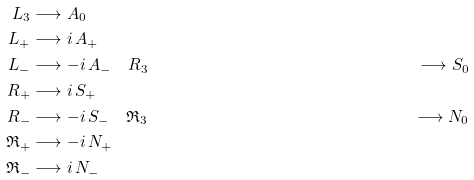Convert formula to latex. <formula><loc_0><loc_0><loc_500><loc_500>L _ { 3 } & \longrightarrow A _ { 0 } \\ L _ { + } & \longrightarrow i \, A _ { + } \\ L _ { - } & \longrightarrow - i \, A _ { - } \quad R _ { 3 } & \longrightarrow S _ { 0 } \\ R _ { + } & \longrightarrow i \, S _ { + } \\ R _ { - } & \longrightarrow - i \, S _ { - } \quad \mathfrak { R } _ { 3 } & \longrightarrow N _ { 0 } \\ \mathfrak { R } _ { + } & \longrightarrow - i \, N _ { + } \\ \mathfrak { R } _ { - } & \longrightarrow i \, N _ { - }</formula> 